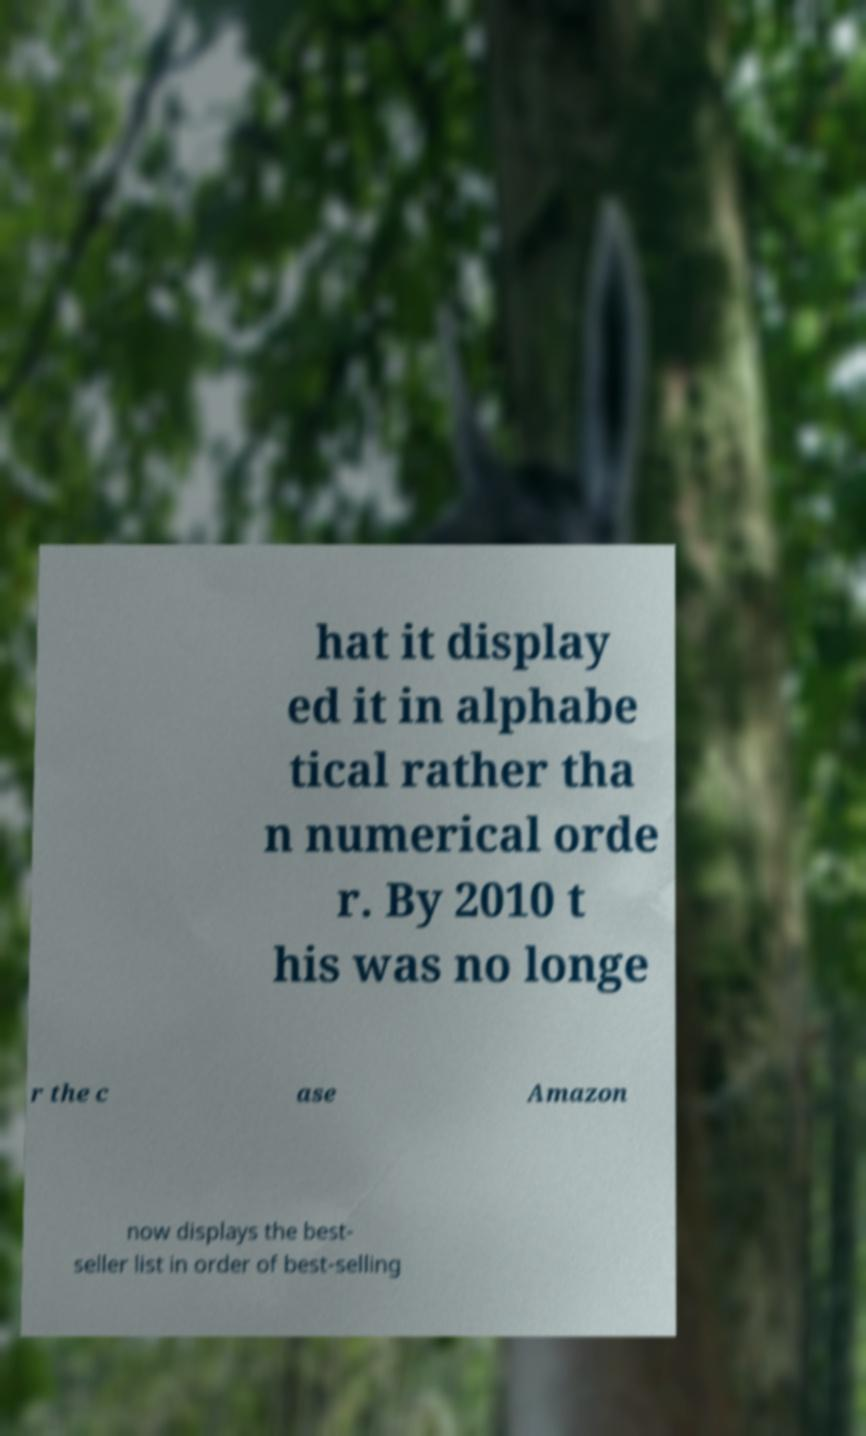Please read and relay the text visible in this image. What does it say? hat it display ed it in alphabe tical rather tha n numerical orde r. By 2010 t his was no longe r the c ase Amazon now displays the best- seller list in order of best-selling 